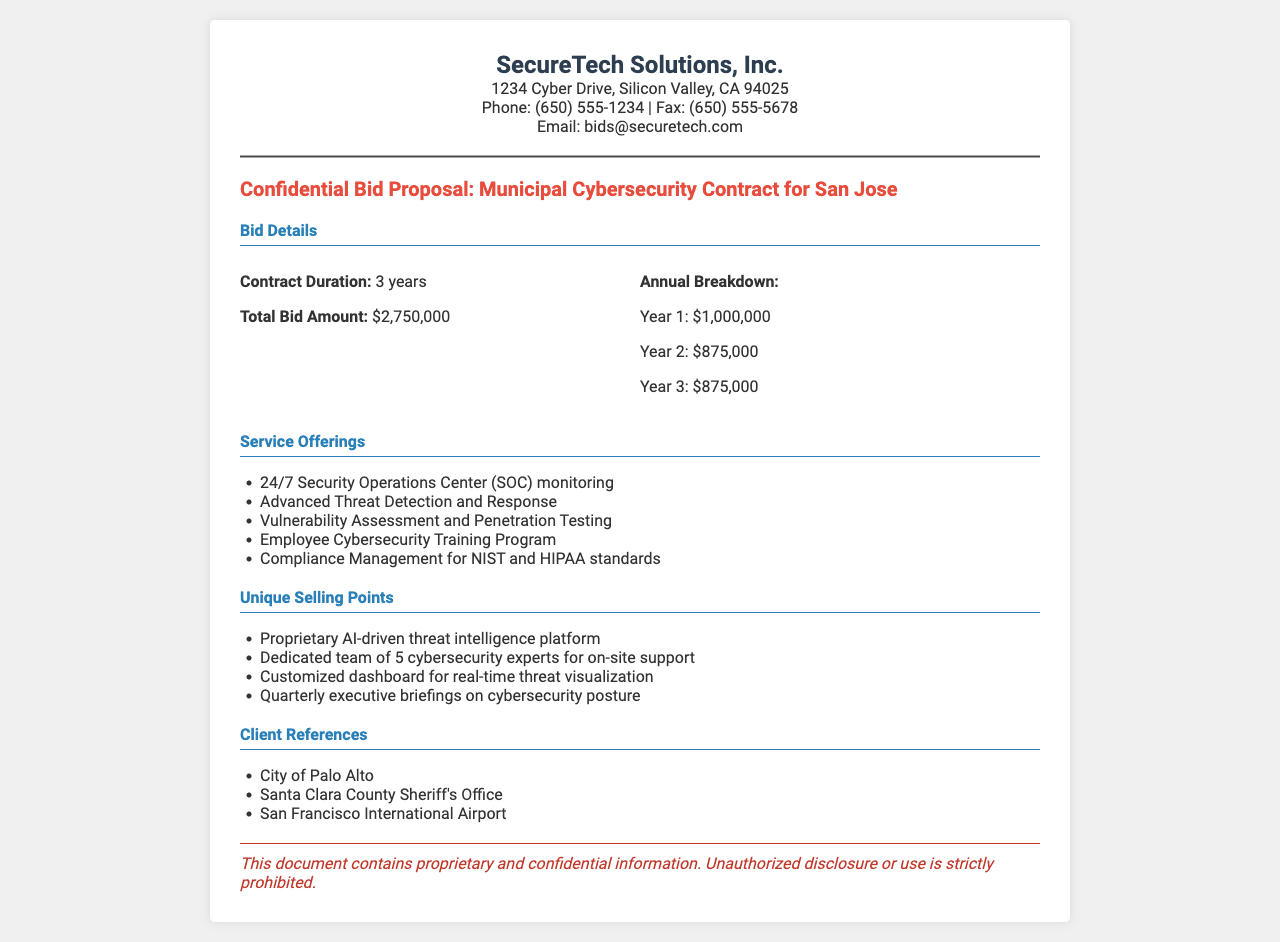what is the total bid amount? The total bid amount is stated clearly in the document under the bid details section.
Answer: $2,750,000 what is the duration of the contract? The duration of the contract is specified in the bid details section, which highlights the timeframe for the agreement.
Answer: 3 years how much is the annual budget for Year 1? The document provides a breakdown of costs for each year, specifically listing the amount for Year 1.
Answer: $1,000,000 which standards does the compliance management cover? The service offerings include a line about compliance management, specifying the standards mentioned.
Answer: NIST and HIPAA what is a unique selling point of SecureTech Solutions? The document includes a section outlining unique selling points, providing specific advantages offered by the company.
Answer: Proprietary AI-driven threat intelligence platform how many cybersecurity experts are dedicated for on-site support? This detail is found in the unique selling points section, indicating the team's size for direct assistance.
Answer: 5 which agencies serve as client references? Client references are listed in a dedicated section of the document, providing examples of previous clients.
Answer: City of Palo Alto, Santa Clara County Sheriff's Office, San Francisco International Airport what is included in the employee training program? The specific offerings of the service can be found in the service offerings section, highlighting training components.
Answer: Employee Cybersecurity Training Program what type of monitoring is offered by the Security Operations Center? The service offerings paragraph informs about what the Security Operations Center provides to clients.
Answer: 24/7 Security Operations Center (SOC) monitoring 